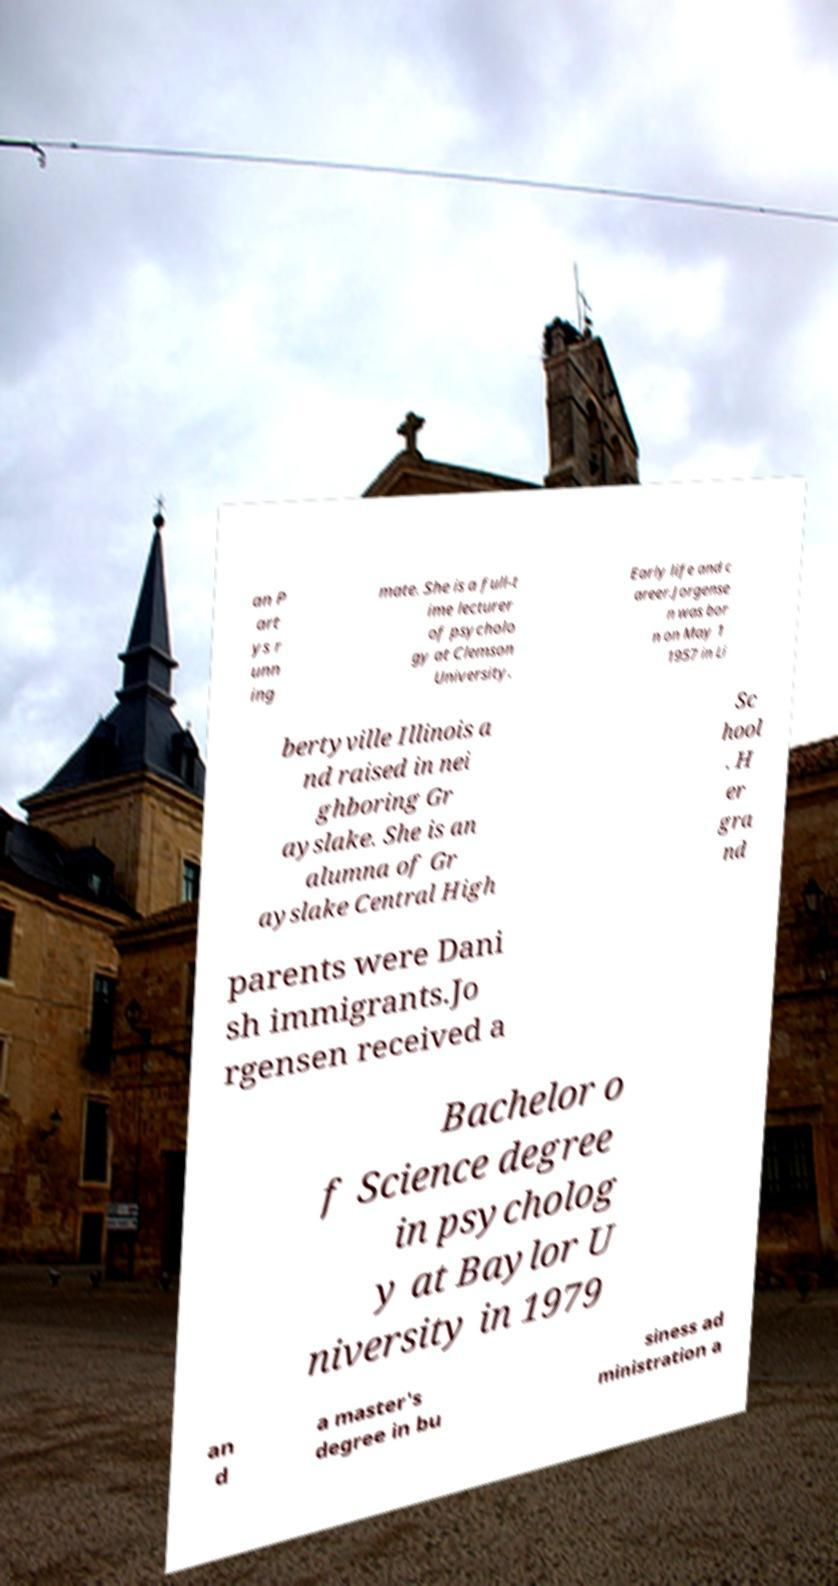Could you extract and type out the text from this image? an P art ys r unn ing mate. She is a full-t ime lecturer of psycholo gy at Clemson University. Early life and c areer.Jorgense n was bor n on May 1 1957 in Li bertyville Illinois a nd raised in nei ghboring Gr ayslake. She is an alumna of Gr ayslake Central High Sc hool . H er gra nd parents were Dani sh immigrants.Jo rgensen received a Bachelor o f Science degree in psycholog y at Baylor U niversity in 1979 an d a master's degree in bu siness ad ministration a 